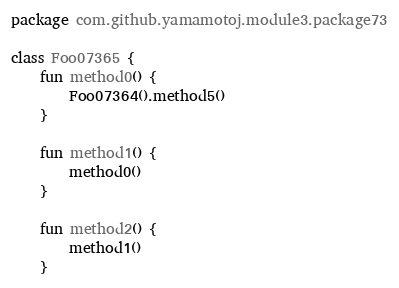Convert code to text. <code><loc_0><loc_0><loc_500><loc_500><_Kotlin_>package com.github.yamamotoj.module3.package73

class Foo07365 {
    fun method0() {
        Foo07364().method5()
    }

    fun method1() {
        method0()
    }

    fun method2() {
        method1()
    }
</code> 